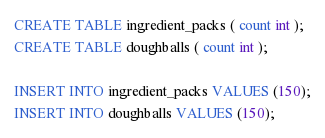<code> <loc_0><loc_0><loc_500><loc_500><_SQL_>CREATE TABLE ingredient_packs ( count int );
CREATE TABLE doughballs ( count int );

INSERT INTO ingredient_packs VALUES (150);
INSERT INTO doughballs VALUES (150);
</code> 